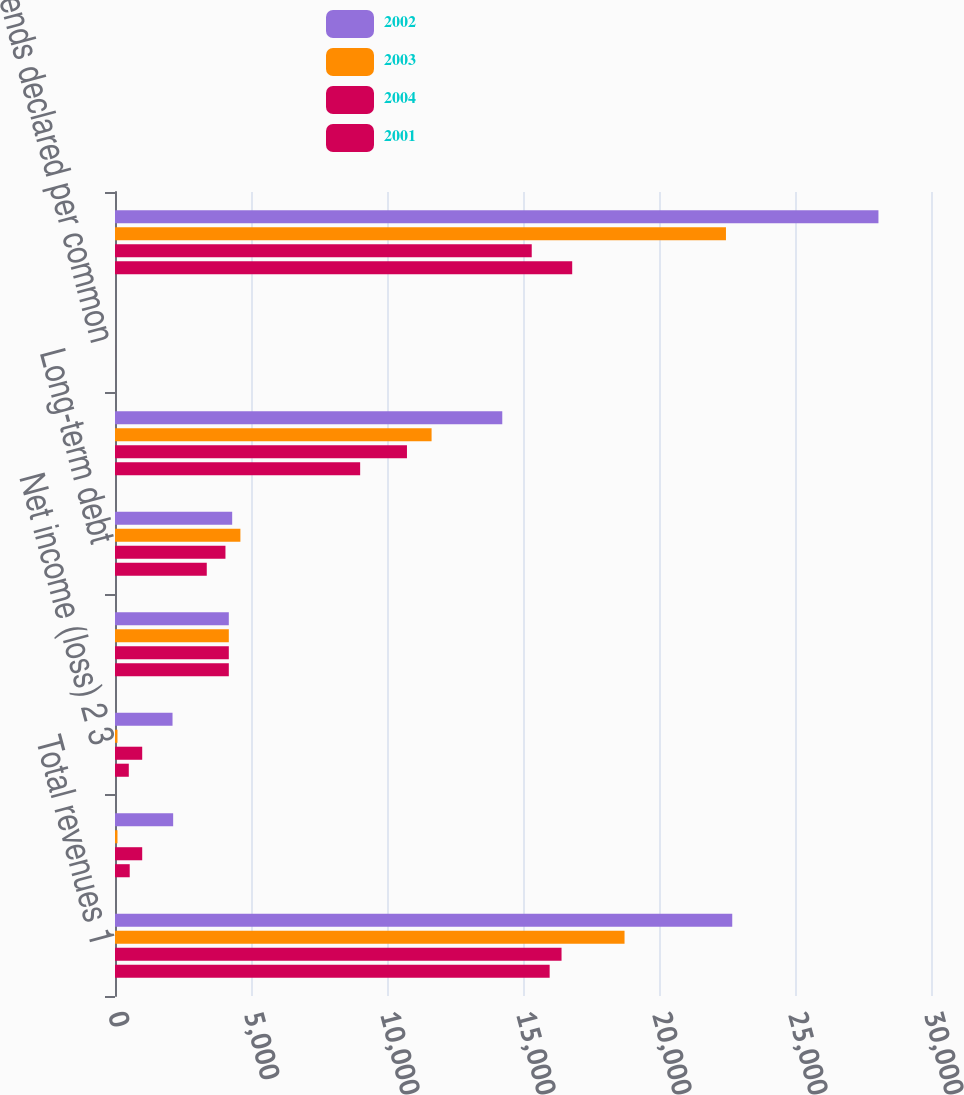<chart> <loc_0><loc_0><loc_500><loc_500><stacked_bar_chart><ecel><fcel>Total revenues 1<fcel>Income (loss) before<fcel>Net income (loss) 2 3<fcel>Total assets<fcel>Long-term debt<fcel>Total stockholders' equity<fcel>Dividends declared per common<fcel>Mutual fund assets 5<nl><fcel>2002<fcel>22693<fcel>2138<fcel>2115<fcel>4184.5<fcel>4308<fcel>14238<fcel>1.13<fcel>28068<nl><fcel>2003<fcel>18733<fcel>91<fcel>91<fcel>4184.5<fcel>4610<fcel>11639<fcel>1.09<fcel>22462<nl><fcel>2004<fcel>16417<fcel>1000<fcel>1000<fcel>4184.5<fcel>4061<fcel>10734<fcel>1.05<fcel>15321<nl><fcel>2001<fcel>15980<fcel>541<fcel>507<fcel>4184.5<fcel>3374<fcel>9013<fcel>1.01<fcel>16809<nl></chart> 